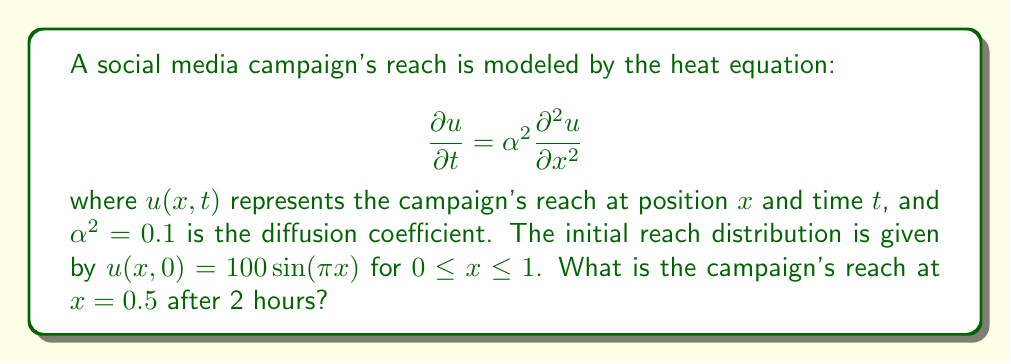Give your solution to this math problem. To solve this problem, we'll use the separation of variables method:

1) The general solution for the heat equation with these boundary conditions is:

   $$u(x,t) = \sum_{n=1}^{\infty} B_n \sin(n\pi x) e^{-\alpha^2 n^2 \pi^2 t}$$

2) Given the initial condition, we only have one term in the series (n = 1):

   $$u(x,0) = 100\sin(\pi x) = B_1 \sin(\pi x)$$

3) Therefore, $B_1 = 100$, and our solution becomes:

   $$u(x,t) = 100 \sin(\pi x) e^{-\alpha^2 \pi^2 t}$$

4) We're asked to find $u(0.5, 2)$. Let's substitute the values:

   $$u(0.5, 2) = 100 \sin(\pi \cdot 0.5) e^{-0.1 \pi^2 \cdot 2}$$

5) Simplify:
   
   $$u(0.5, 2) = 100 \cdot 1 \cdot e^{-0.2 \pi^2}$$

6) Calculate the result:

   $$u(0.5, 2) \approx 13.5331$$
Answer: 13.53 